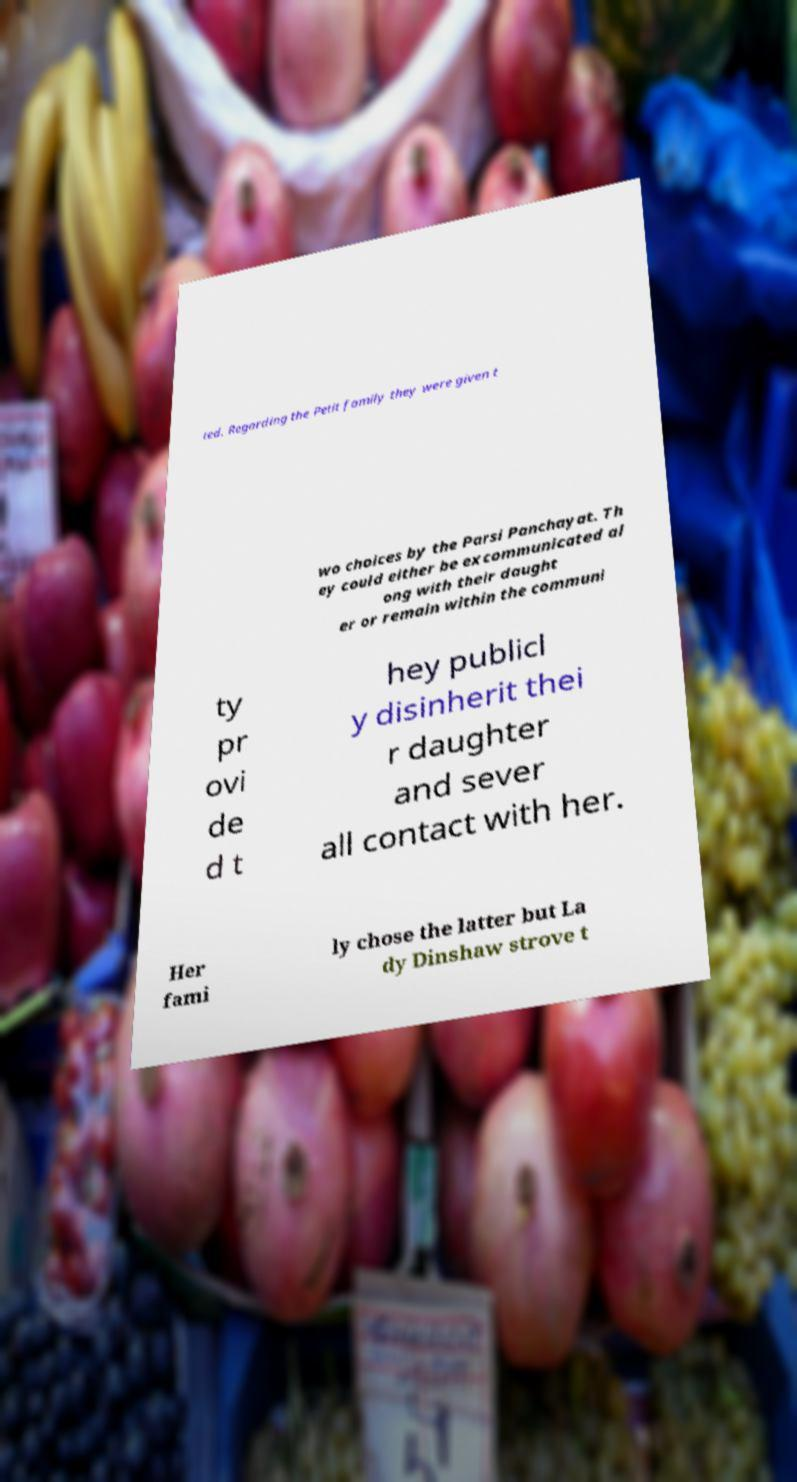Please identify and transcribe the text found in this image. ted. Regarding the Petit family they were given t wo choices by the Parsi Panchayat. Th ey could either be excommunicated al ong with their daught er or remain within the communi ty pr ovi de d t hey publicl y disinherit thei r daughter and sever all contact with her. Her fami ly chose the latter but La dy Dinshaw strove t 